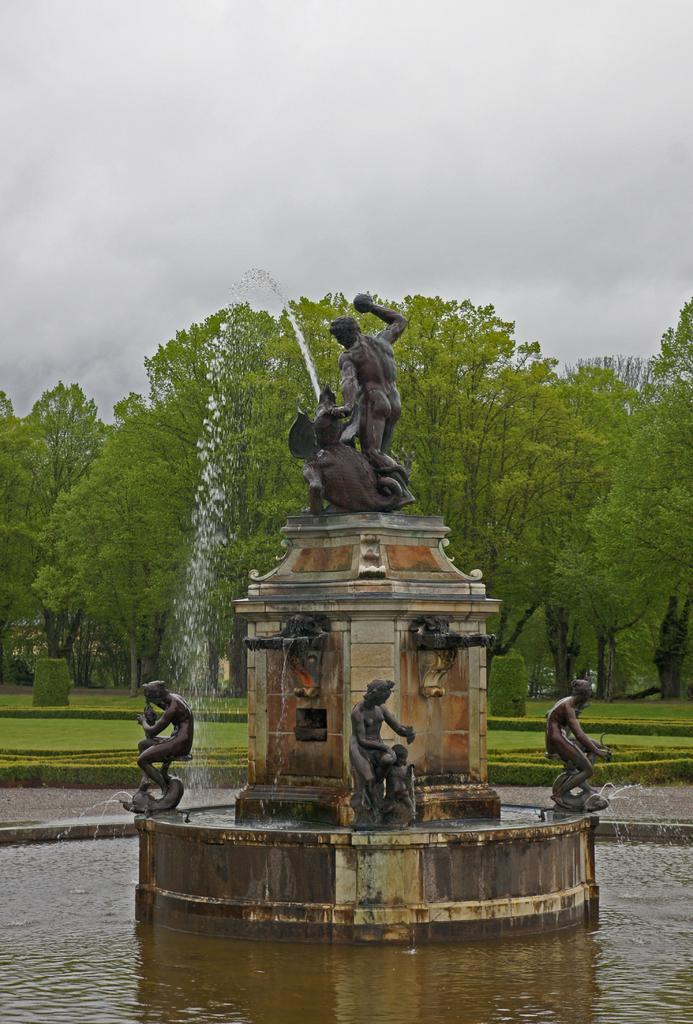In one or two sentences, can you explain what this image depicts? In this image, we can see some statues and the waterfall. We can also see the ground. We can see some grass, plants and trees. We can also see the sky. 